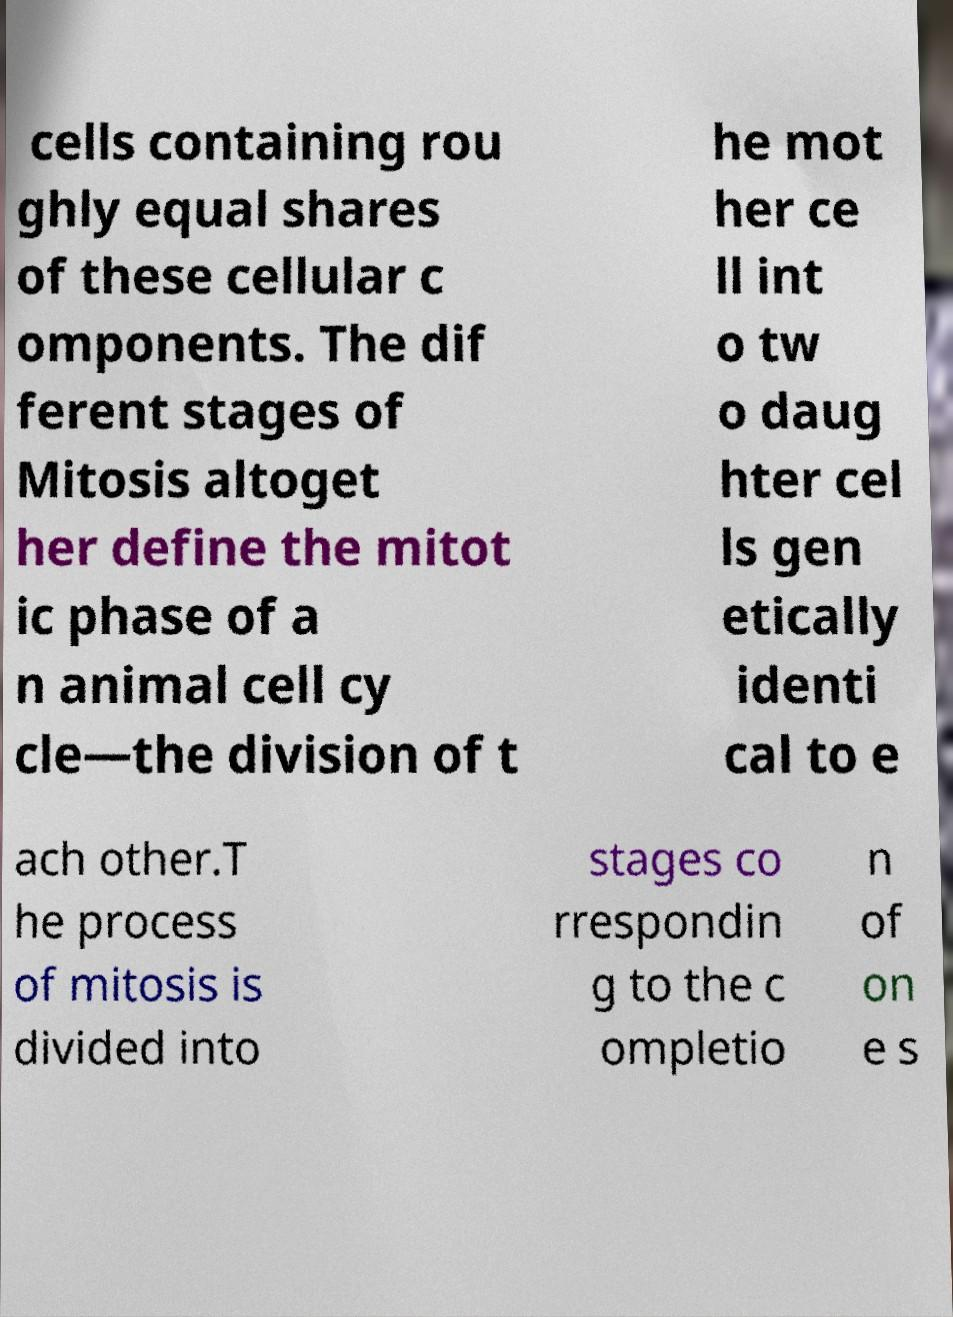Please read and relay the text visible in this image. What does it say? cells containing rou ghly equal shares of these cellular c omponents. The dif ferent stages of Mitosis altoget her define the mitot ic phase of a n animal cell cy cle—the division of t he mot her ce ll int o tw o daug hter cel ls gen etically identi cal to e ach other.T he process of mitosis is divided into stages co rrespondin g to the c ompletio n of on e s 